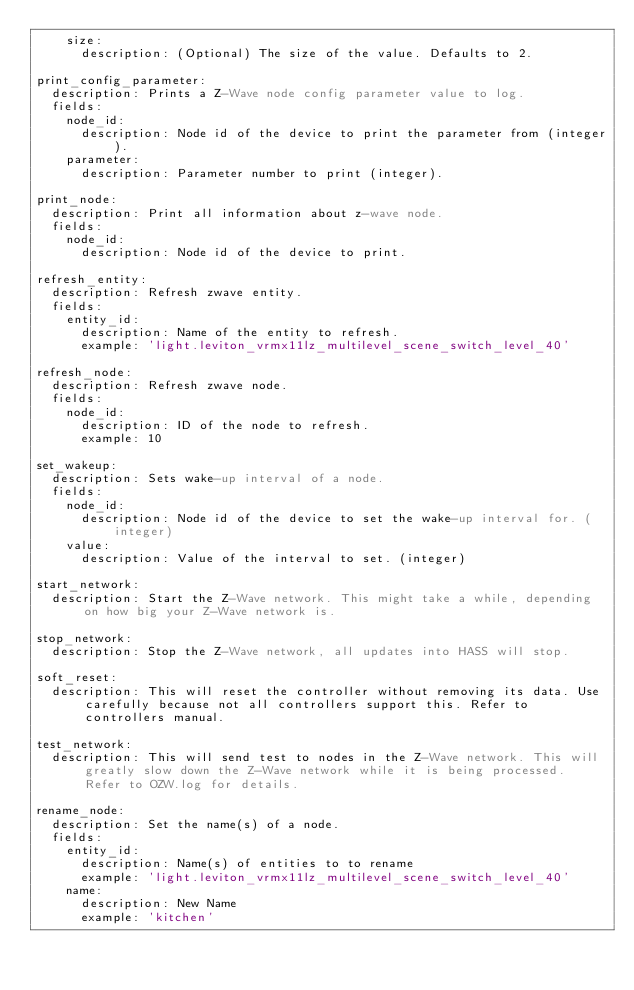Convert code to text. <code><loc_0><loc_0><loc_500><loc_500><_YAML_>    size:
      description: (Optional) The size of the value. Defaults to 2.

print_config_parameter:
  description: Prints a Z-Wave node config parameter value to log.
  fields:
    node_id:
      description: Node id of the device to print the parameter from (integer).
    parameter:
      description: Parameter number to print (integer).

print_node:
  description: Print all information about z-wave node.
  fields:
    node_id:
      description: Node id of the device to print.

refresh_entity:
  description: Refresh zwave entity.
  fields:
    entity_id:
      description: Name of the entity to refresh.
      example: 'light.leviton_vrmx11lz_multilevel_scene_switch_level_40'

refresh_node:
  description: Refresh zwave node.
  fields:
    node_id:
      description: ID of the node to refresh.
      example: 10

set_wakeup:
  description: Sets wake-up interval of a node.
  fields:
    node_id:
      description: Node id of the device to set the wake-up interval for. (integer)
    value:
      description: Value of the interval to set. (integer)

start_network:
  description: Start the Z-Wave network. This might take a while, depending on how big your Z-Wave network is.

stop_network:
  description: Stop the Z-Wave network, all updates into HASS will stop.

soft_reset:
  description: This will reset the controller without removing its data. Use carefully because not all controllers support this. Refer to controllers manual.

test_network:
  description: This will send test to nodes in the Z-Wave network. This will greatly slow down the Z-Wave network while it is being processed. Refer to OZW.log for details.

rename_node:
  description: Set the name(s) of a node.
  fields:
    entity_id:
      description: Name(s) of entities to to rename
      example: 'light.leviton_vrmx11lz_multilevel_scene_switch_level_40'
    name:
      description: New Name
      example: 'kitchen'
</code> 